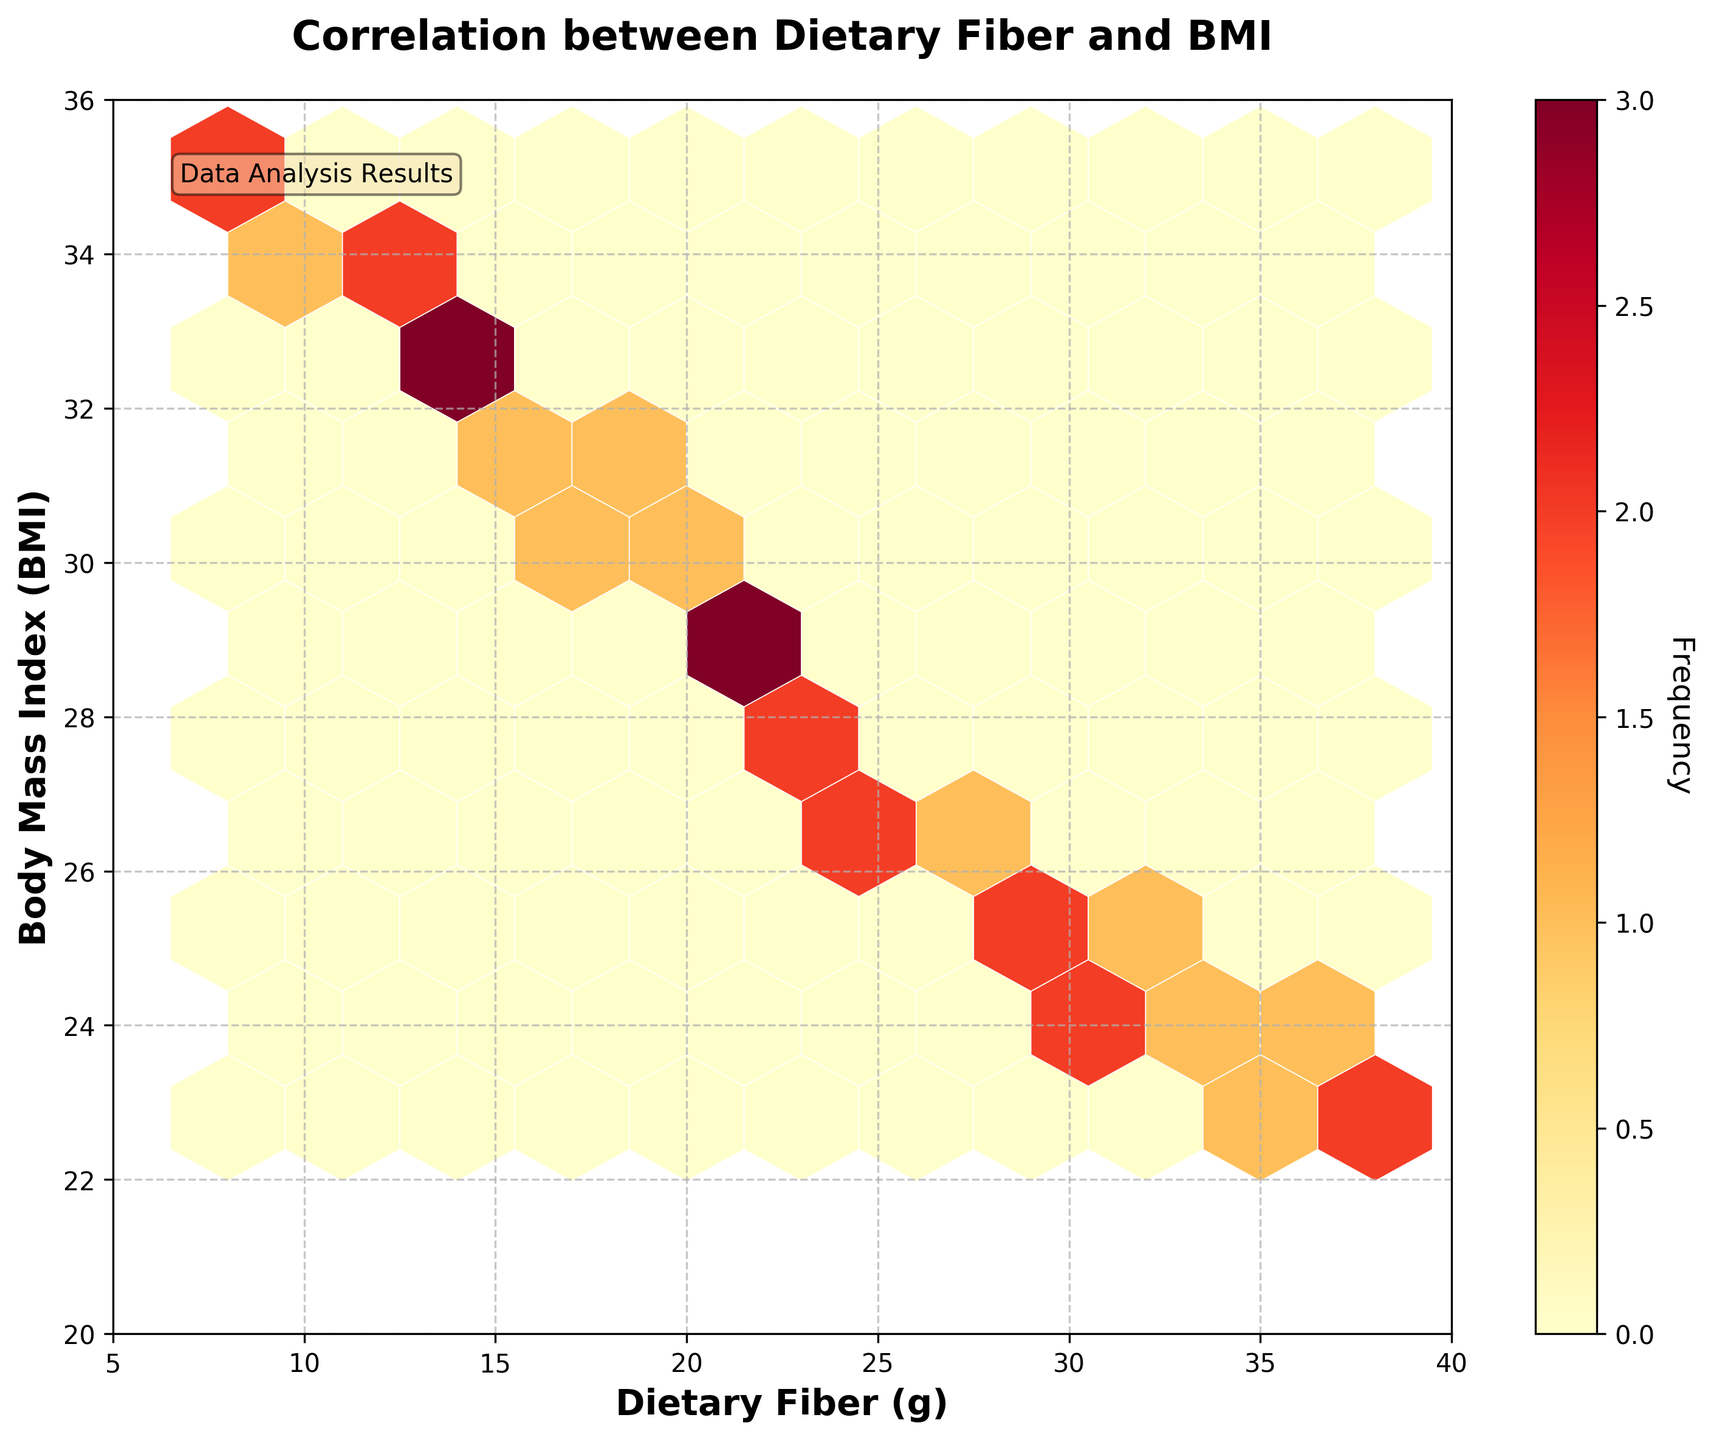What is the title of the hexbin plot? The title of the hexbin plot is shown at the top of the figure.
Answer: Correlation between Dietary Fiber and BMI What does the color represent in the hexbin plot? The color in the hexbin plot represents the frequency of data points within each hexagon.
Answer: Frequency What is the range of BMI shown on the y-axis? By looking at the labels on the y-axis, you can determine the range of BMI values.
Answer: 20 to 36 Which dietary fiber value appears to have the highest frequency of data points? The hexagon with the darkest color represents the highest frequency. Looking at the x-axis, you can locate the approximate dietary fiber value.
Answer: Around 16 to 20 grams Does high dietary fiber consumption correlate with higher or lower BMI values? Observing the plot shows that higher dietary fiber consumption tends to be associated with lower BMI values. The hexagons with higher dietary fiber values generally correspond to lower BMI values.
Answer: Lower What is the x-axis label in the hexbin plot? The label is shown along the x-axis at the bottom of the figure.
Answer: Dietary Fiber (g) Describe the relationship between dietary fiber and BMI as observed in the hexbin plot. The hexbin plot shows a negative correlation between dietary fiber and BMI. As the dietary fiber consumption increases, the BMI tends to decrease, indicated by the distribution trend of the hexagons.
Answer: Negative correlation How is the data spread along the x-axis for dietary fiber? The x-axis shows dietary fiber values ranging from 5 to 40 grams with data points spread relatively evenly across this range except for lower densities at the extremes.
Answer: 5 to 40 grams Which dietary fiber values correspond to the lowest BMI values in the plot? The hexagons with the lowest BMI values are found towards the higher end of the dietary fiber range. By looking at the top of the y-axis (lower BMI values) and moving horizontally, you can determine this.
Answer: 35 to 38 grams How can you tell the plot includes a data analysis result annotation? The annotation is placed within the plot, typically enclosed in a box, giving additional context about the data. It usually provides an analysis summary or data insights.
Answer: "Data Analysis Results" 